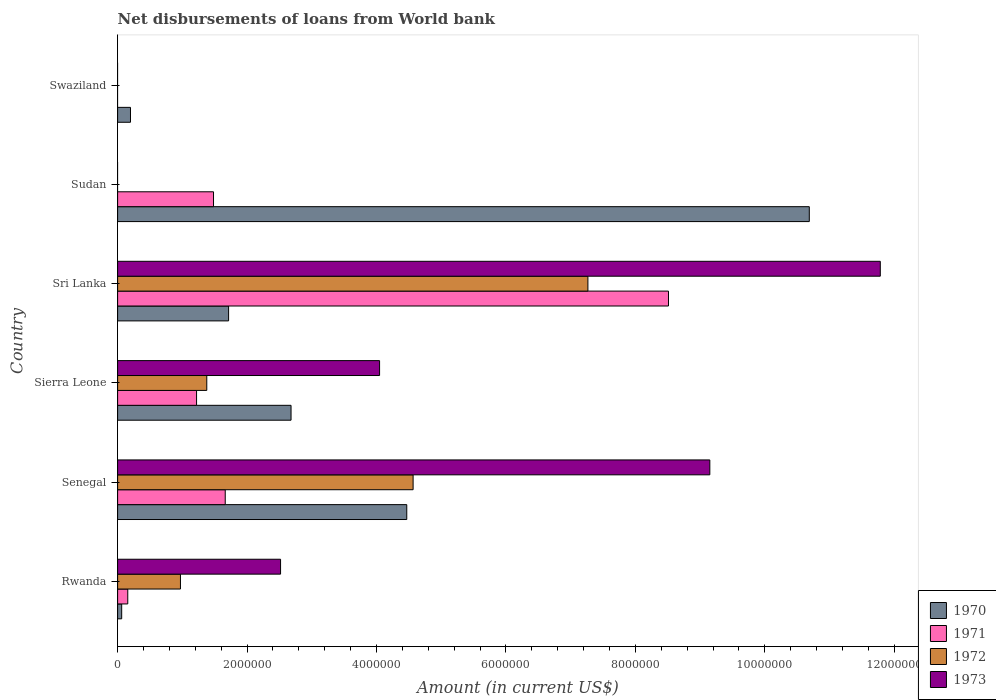How many different coloured bars are there?
Provide a succinct answer. 4. What is the label of the 1st group of bars from the top?
Your answer should be compact. Swaziland. What is the amount of loan disbursed from World Bank in 1971 in Swaziland?
Provide a succinct answer. 0. Across all countries, what is the maximum amount of loan disbursed from World Bank in 1971?
Provide a succinct answer. 8.51e+06. In which country was the amount of loan disbursed from World Bank in 1973 maximum?
Provide a short and direct response. Sri Lanka. What is the total amount of loan disbursed from World Bank in 1971 in the graph?
Provide a succinct answer. 1.30e+07. What is the difference between the amount of loan disbursed from World Bank in 1971 in Sierra Leone and that in Sri Lanka?
Provide a short and direct response. -7.29e+06. What is the difference between the amount of loan disbursed from World Bank in 1972 in Sudan and the amount of loan disbursed from World Bank in 1973 in Sri Lanka?
Provide a short and direct response. -1.18e+07. What is the average amount of loan disbursed from World Bank in 1973 per country?
Provide a succinct answer. 4.58e+06. What is the difference between the amount of loan disbursed from World Bank in 1973 and amount of loan disbursed from World Bank in 1972 in Sri Lanka?
Your answer should be very brief. 4.52e+06. What is the ratio of the amount of loan disbursed from World Bank in 1971 in Senegal to that in Sri Lanka?
Your answer should be very brief. 0.2. Is the amount of loan disbursed from World Bank in 1970 in Rwanda less than that in Sudan?
Give a very brief answer. Yes. Is the difference between the amount of loan disbursed from World Bank in 1973 in Rwanda and Sierra Leone greater than the difference between the amount of loan disbursed from World Bank in 1972 in Rwanda and Sierra Leone?
Offer a terse response. No. What is the difference between the highest and the second highest amount of loan disbursed from World Bank in 1973?
Your response must be concise. 2.63e+06. What is the difference between the highest and the lowest amount of loan disbursed from World Bank in 1970?
Provide a short and direct response. 1.06e+07. Is the sum of the amount of loan disbursed from World Bank in 1971 in Sri Lanka and Sudan greater than the maximum amount of loan disbursed from World Bank in 1970 across all countries?
Offer a terse response. No. Is it the case that in every country, the sum of the amount of loan disbursed from World Bank in 1970 and amount of loan disbursed from World Bank in 1971 is greater than the sum of amount of loan disbursed from World Bank in 1973 and amount of loan disbursed from World Bank in 1972?
Your answer should be very brief. No. Is it the case that in every country, the sum of the amount of loan disbursed from World Bank in 1971 and amount of loan disbursed from World Bank in 1972 is greater than the amount of loan disbursed from World Bank in 1970?
Make the answer very short. No. How many bars are there?
Give a very brief answer. 19. Are all the bars in the graph horizontal?
Offer a very short reply. Yes. What is the difference between two consecutive major ticks on the X-axis?
Provide a short and direct response. 2.00e+06. Are the values on the major ticks of X-axis written in scientific E-notation?
Keep it short and to the point. No. How are the legend labels stacked?
Offer a terse response. Vertical. What is the title of the graph?
Offer a terse response. Net disbursements of loans from World bank. Does "2012" appear as one of the legend labels in the graph?
Ensure brevity in your answer.  No. What is the label or title of the Y-axis?
Your answer should be compact. Country. What is the Amount (in current US$) in 1970 in Rwanda?
Your answer should be compact. 6.30e+04. What is the Amount (in current US$) in 1971 in Rwanda?
Provide a succinct answer. 1.57e+05. What is the Amount (in current US$) in 1972 in Rwanda?
Provide a succinct answer. 9.71e+05. What is the Amount (in current US$) in 1973 in Rwanda?
Your answer should be very brief. 2.52e+06. What is the Amount (in current US$) of 1970 in Senegal?
Give a very brief answer. 4.47e+06. What is the Amount (in current US$) of 1971 in Senegal?
Give a very brief answer. 1.66e+06. What is the Amount (in current US$) in 1972 in Senegal?
Ensure brevity in your answer.  4.57e+06. What is the Amount (in current US$) of 1973 in Senegal?
Your response must be concise. 9.15e+06. What is the Amount (in current US$) in 1970 in Sierra Leone?
Provide a short and direct response. 2.68e+06. What is the Amount (in current US$) in 1971 in Sierra Leone?
Your response must be concise. 1.22e+06. What is the Amount (in current US$) in 1972 in Sierra Leone?
Your answer should be compact. 1.38e+06. What is the Amount (in current US$) of 1973 in Sierra Leone?
Your response must be concise. 4.05e+06. What is the Amount (in current US$) in 1970 in Sri Lanka?
Your answer should be compact. 1.72e+06. What is the Amount (in current US$) in 1971 in Sri Lanka?
Give a very brief answer. 8.51e+06. What is the Amount (in current US$) of 1972 in Sri Lanka?
Ensure brevity in your answer.  7.27e+06. What is the Amount (in current US$) of 1973 in Sri Lanka?
Provide a short and direct response. 1.18e+07. What is the Amount (in current US$) in 1970 in Sudan?
Provide a succinct answer. 1.07e+07. What is the Amount (in current US$) of 1971 in Sudan?
Your answer should be very brief. 1.48e+06. What is the Amount (in current US$) of 1972 in Sudan?
Your answer should be compact. 0. What is the Amount (in current US$) in 1970 in Swaziland?
Ensure brevity in your answer.  1.99e+05. What is the Amount (in current US$) in 1972 in Swaziland?
Give a very brief answer. 0. Across all countries, what is the maximum Amount (in current US$) in 1970?
Provide a short and direct response. 1.07e+07. Across all countries, what is the maximum Amount (in current US$) in 1971?
Ensure brevity in your answer.  8.51e+06. Across all countries, what is the maximum Amount (in current US$) of 1972?
Ensure brevity in your answer.  7.27e+06. Across all countries, what is the maximum Amount (in current US$) in 1973?
Offer a very short reply. 1.18e+07. Across all countries, what is the minimum Amount (in current US$) of 1970?
Keep it short and to the point. 6.30e+04. Across all countries, what is the minimum Amount (in current US$) of 1971?
Ensure brevity in your answer.  0. Across all countries, what is the minimum Amount (in current US$) of 1972?
Offer a terse response. 0. What is the total Amount (in current US$) of 1970 in the graph?
Your answer should be compact. 1.98e+07. What is the total Amount (in current US$) in 1971 in the graph?
Keep it short and to the point. 1.30e+07. What is the total Amount (in current US$) of 1972 in the graph?
Give a very brief answer. 1.42e+07. What is the total Amount (in current US$) in 1973 in the graph?
Give a very brief answer. 2.75e+07. What is the difference between the Amount (in current US$) of 1970 in Rwanda and that in Senegal?
Offer a very short reply. -4.40e+06. What is the difference between the Amount (in current US$) in 1971 in Rwanda and that in Senegal?
Provide a succinct answer. -1.51e+06. What is the difference between the Amount (in current US$) in 1972 in Rwanda and that in Senegal?
Make the answer very short. -3.60e+06. What is the difference between the Amount (in current US$) in 1973 in Rwanda and that in Senegal?
Your answer should be compact. -6.63e+06. What is the difference between the Amount (in current US$) in 1970 in Rwanda and that in Sierra Leone?
Your answer should be compact. -2.62e+06. What is the difference between the Amount (in current US$) of 1971 in Rwanda and that in Sierra Leone?
Keep it short and to the point. -1.06e+06. What is the difference between the Amount (in current US$) of 1972 in Rwanda and that in Sierra Leone?
Make the answer very short. -4.07e+05. What is the difference between the Amount (in current US$) in 1973 in Rwanda and that in Sierra Leone?
Provide a short and direct response. -1.53e+06. What is the difference between the Amount (in current US$) in 1970 in Rwanda and that in Sri Lanka?
Provide a succinct answer. -1.65e+06. What is the difference between the Amount (in current US$) of 1971 in Rwanda and that in Sri Lanka?
Provide a short and direct response. -8.36e+06. What is the difference between the Amount (in current US$) of 1972 in Rwanda and that in Sri Lanka?
Provide a succinct answer. -6.30e+06. What is the difference between the Amount (in current US$) in 1973 in Rwanda and that in Sri Lanka?
Ensure brevity in your answer.  -9.27e+06. What is the difference between the Amount (in current US$) of 1970 in Rwanda and that in Sudan?
Make the answer very short. -1.06e+07. What is the difference between the Amount (in current US$) in 1971 in Rwanda and that in Sudan?
Ensure brevity in your answer.  -1.32e+06. What is the difference between the Amount (in current US$) in 1970 in Rwanda and that in Swaziland?
Provide a succinct answer. -1.36e+05. What is the difference between the Amount (in current US$) of 1970 in Senegal and that in Sierra Leone?
Offer a terse response. 1.79e+06. What is the difference between the Amount (in current US$) in 1971 in Senegal and that in Sierra Leone?
Keep it short and to the point. 4.43e+05. What is the difference between the Amount (in current US$) in 1972 in Senegal and that in Sierra Leone?
Keep it short and to the point. 3.19e+06. What is the difference between the Amount (in current US$) in 1973 in Senegal and that in Sierra Leone?
Make the answer very short. 5.10e+06. What is the difference between the Amount (in current US$) of 1970 in Senegal and that in Sri Lanka?
Offer a terse response. 2.75e+06. What is the difference between the Amount (in current US$) of 1971 in Senegal and that in Sri Lanka?
Make the answer very short. -6.85e+06. What is the difference between the Amount (in current US$) of 1972 in Senegal and that in Sri Lanka?
Give a very brief answer. -2.70e+06. What is the difference between the Amount (in current US$) in 1973 in Senegal and that in Sri Lanka?
Your answer should be compact. -2.63e+06. What is the difference between the Amount (in current US$) of 1970 in Senegal and that in Sudan?
Offer a very short reply. -6.22e+06. What is the difference between the Amount (in current US$) of 1971 in Senegal and that in Sudan?
Your answer should be very brief. 1.81e+05. What is the difference between the Amount (in current US$) in 1970 in Senegal and that in Swaziland?
Your answer should be very brief. 4.27e+06. What is the difference between the Amount (in current US$) of 1970 in Sierra Leone and that in Sri Lanka?
Give a very brief answer. 9.65e+05. What is the difference between the Amount (in current US$) in 1971 in Sierra Leone and that in Sri Lanka?
Give a very brief answer. -7.29e+06. What is the difference between the Amount (in current US$) in 1972 in Sierra Leone and that in Sri Lanka?
Provide a succinct answer. -5.89e+06. What is the difference between the Amount (in current US$) in 1973 in Sierra Leone and that in Sri Lanka?
Keep it short and to the point. -7.74e+06. What is the difference between the Amount (in current US$) of 1970 in Sierra Leone and that in Sudan?
Ensure brevity in your answer.  -8.01e+06. What is the difference between the Amount (in current US$) of 1971 in Sierra Leone and that in Sudan?
Your response must be concise. -2.62e+05. What is the difference between the Amount (in current US$) of 1970 in Sierra Leone and that in Swaziland?
Offer a very short reply. 2.48e+06. What is the difference between the Amount (in current US$) in 1970 in Sri Lanka and that in Sudan?
Offer a terse response. -8.97e+06. What is the difference between the Amount (in current US$) in 1971 in Sri Lanka and that in Sudan?
Your answer should be compact. 7.03e+06. What is the difference between the Amount (in current US$) in 1970 in Sri Lanka and that in Swaziland?
Your answer should be very brief. 1.52e+06. What is the difference between the Amount (in current US$) of 1970 in Sudan and that in Swaziland?
Ensure brevity in your answer.  1.05e+07. What is the difference between the Amount (in current US$) in 1970 in Rwanda and the Amount (in current US$) in 1971 in Senegal?
Your response must be concise. -1.60e+06. What is the difference between the Amount (in current US$) of 1970 in Rwanda and the Amount (in current US$) of 1972 in Senegal?
Your answer should be compact. -4.50e+06. What is the difference between the Amount (in current US$) of 1970 in Rwanda and the Amount (in current US$) of 1973 in Senegal?
Ensure brevity in your answer.  -9.09e+06. What is the difference between the Amount (in current US$) of 1971 in Rwanda and the Amount (in current US$) of 1972 in Senegal?
Keep it short and to the point. -4.41e+06. What is the difference between the Amount (in current US$) in 1971 in Rwanda and the Amount (in current US$) in 1973 in Senegal?
Your answer should be very brief. -8.99e+06. What is the difference between the Amount (in current US$) of 1972 in Rwanda and the Amount (in current US$) of 1973 in Senegal?
Offer a very short reply. -8.18e+06. What is the difference between the Amount (in current US$) in 1970 in Rwanda and the Amount (in current US$) in 1971 in Sierra Leone?
Offer a terse response. -1.16e+06. What is the difference between the Amount (in current US$) of 1970 in Rwanda and the Amount (in current US$) of 1972 in Sierra Leone?
Provide a short and direct response. -1.32e+06. What is the difference between the Amount (in current US$) in 1970 in Rwanda and the Amount (in current US$) in 1973 in Sierra Leone?
Your answer should be very brief. -3.98e+06. What is the difference between the Amount (in current US$) in 1971 in Rwanda and the Amount (in current US$) in 1972 in Sierra Leone?
Offer a very short reply. -1.22e+06. What is the difference between the Amount (in current US$) in 1971 in Rwanda and the Amount (in current US$) in 1973 in Sierra Leone?
Provide a short and direct response. -3.89e+06. What is the difference between the Amount (in current US$) of 1972 in Rwanda and the Amount (in current US$) of 1973 in Sierra Leone?
Give a very brief answer. -3.08e+06. What is the difference between the Amount (in current US$) in 1970 in Rwanda and the Amount (in current US$) in 1971 in Sri Lanka?
Provide a short and direct response. -8.45e+06. What is the difference between the Amount (in current US$) in 1970 in Rwanda and the Amount (in current US$) in 1972 in Sri Lanka?
Your response must be concise. -7.20e+06. What is the difference between the Amount (in current US$) in 1970 in Rwanda and the Amount (in current US$) in 1973 in Sri Lanka?
Your answer should be very brief. -1.17e+07. What is the difference between the Amount (in current US$) of 1971 in Rwanda and the Amount (in current US$) of 1972 in Sri Lanka?
Offer a terse response. -7.11e+06. What is the difference between the Amount (in current US$) of 1971 in Rwanda and the Amount (in current US$) of 1973 in Sri Lanka?
Offer a very short reply. -1.16e+07. What is the difference between the Amount (in current US$) of 1972 in Rwanda and the Amount (in current US$) of 1973 in Sri Lanka?
Your answer should be very brief. -1.08e+07. What is the difference between the Amount (in current US$) of 1970 in Rwanda and the Amount (in current US$) of 1971 in Sudan?
Offer a very short reply. -1.42e+06. What is the difference between the Amount (in current US$) of 1970 in Senegal and the Amount (in current US$) of 1971 in Sierra Leone?
Offer a terse response. 3.25e+06. What is the difference between the Amount (in current US$) of 1970 in Senegal and the Amount (in current US$) of 1972 in Sierra Leone?
Make the answer very short. 3.09e+06. What is the difference between the Amount (in current US$) of 1970 in Senegal and the Amount (in current US$) of 1973 in Sierra Leone?
Provide a short and direct response. 4.20e+05. What is the difference between the Amount (in current US$) of 1971 in Senegal and the Amount (in current US$) of 1972 in Sierra Leone?
Ensure brevity in your answer.  2.85e+05. What is the difference between the Amount (in current US$) in 1971 in Senegal and the Amount (in current US$) in 1973 in Sierra Leone?
Offer a very short reply. -2.38e+06. What is the difference between the Amount (in current US$) in 1972 in Senegal and the Amount (in current US$) in 1973 in Sierra Leone?
Give a very brief answer. 5.18e+05. What is the difference between the Amount (in current US$) in 1970 in Senegal and the Amount (in current US$) in 1971 in Sri Lanka?
Your answer should be compact. -4.04e+06. What is the difference between the Amount (in current US$) of 1970 in Senegal and the Amount (in current US$) of 1972 in Sri Lanka?
Your response must be concise. -2.80e+06. What is the difference between the Amount (in current US$) in 1970 in Senegal and the Amount (in current US$) in 1973 in Sri Lanka?
Offer a very short reply. -7.32e+06. What is the difference between the Amount (in current US$) in 1971 in Senegal and the Amount (in current US$) in 1972 in Sri Lanka?
Give a very brief answer. -5.60e+06. What is the difference between the Amount (in current US$) in 1971 in Senegal and the Amount (in current US$) in 1973 in Sri Lanka?
Offer a terse response. -1.01e+07. What is the difference between the Amount (in current US$) in 1972 in Senegal and the Amount (in current US$) in 1973 in Sri Lanka?
Your response must be concise. -7.22e+06. What is the difference between the Amount (in current US$) in 1970 in Senegal and the Amount (in current US$) in 1971 in Sudan?
Provide a short and direct response. 2.99e+06. What is the difference between the Amount (in current US$) in 1970 in Sierra Leone and the Amount (in current US$) in 1971 in Sri Lanka?
Your answer should be compact. -5.83e+06. What is the difference between the Amount (in current US$) in 1970 in Sierra Leone and the Amount (in current US$) in 1972 in Sri Lanka?
Provide a succinct answer. -4.59e+06. What is the difference between the Amount (in current US$) in 1970 in Sierra Leone and the Amount (in current US$) in 1973 in Sri Lanka?
Keep it short and to the point. -9.10e+06. What is the difference between the Amount (in current US$) of 1971 in Sierra Leone and the Amount (in current US$) of 1972 in Sri Lanka?
Provide a short and direct response. -6.05e+06. What is the difference between the Amount (in current US$) of 1971 in Sierra Leone and the Amount (in current US$) of 1973 in Sri Lanka?
Make the answer very short. -1.06e+07. What is the difference between the Amount (in current US$) of 1972 in Sierra Leone and the Amount (in current US$) of 1973 in Sri Lanka?
Give a very brief answer. -1.04e+07. What is the difference between the Amount (in current US$) in 1970 in Sierra Leone and the Amount (in current US$) in 1971 in Sudan?
Provide a short and direct response. 1.20e+06. What is the difference between the Amount (in current US$) of 1970 in Sri Lanka and the Amount (in current US$) of 1971 in Sudan?
Provide a succinct answer. 2.33e+05. What is the average Amount (in current US$) of 1970 per country?
Your response must be concise. 3.30e+06. What is the average Amount (in current US$) of 1971 per country?
Offer a very short reply. 2.17e+06. What is the average Amount (in current US$) in 1972 per country?
Offer a very short reply. 2.36e+06. What is the average Amount (in current US$) in 1973 per country?
Give a very brief answer. 4.58e+06. What is the difference between the Amount (in current US$) in 1970 and Amount (in current US$) in 1971 in Rwanda?
Give a very brief answer. -9.40e+04. What is the difference between the Amount (in current US$) in 1970 and Amount (in current US$) in 1972 in Rwanda?
Make the answer very short. -9.08e+05. What is the difference between the Amount (in current US$) in 1970 and Amount (in current US$) in 1973 in Rwanda?
Make the answer very short. -2.46e+06. What is the difference between the Amount (in current US$) in 1971 and Amount (in current US$) in 1972 in Rwanda?
Your response must be concise. -8.14e+05. What is the difference between the Amount (in current US$) in 1971 and Amount (in current US$) in 1973 in Rwanda?
Provide a succinct answer. -2.36e+06. What is the difference between the Amount (in current US$) in 1972 and Amount (in current US$) in 1973 in Rwanda?
Your answer should be very brief. -1.55e+06. What is the difference between the Amount (in current US$) in 1970 and Amount (in current US$) in 1971 in Senegal?
Offer a very short reply. 2.80e+06. What is the difference between the Amount (in current US$) of 1970 and Amount (in current US$) of 1972 in Senegal?
Provide a short and direct response. -9.80e+04. What is the difference between the Amount (in current US$) in 1970 and Amount (in current US$) in 1973 in Senegal?
Provide a succinct answer. -4.68e+06. What is the difference between the Amount (in current US$) of 1971 and Amount (in current US$) of 1972 in Senegal?
Ensure brevity in your answer.  -2.90e+06. What is the difference between the Amount (in current US$) in 1971 and Amount (in current US$) in 1973 in Senegal?
Provide a succinct answer. -7.49e+06. What is the difference between the Amount (in current US$) in 1972 and Amount (in current US$) in 1973 in Senegal?
Provide a short and direct response. -4.58e+06. What is the difference between the Amount (in current US$) in 1970 and Amount (in current US$) in 1971 in Sierra Leone?
Offer a terse response. 1.46e+06. What is the difference between the Amount (in current US$) in 1970 and Amount (in current US$) in 1972 in Sierra Leone?
Give a very brief answer. 1.30e+06. What is the difference between the Amount (in current US$) of 1970 and Amount (in current US$) of 1973 in Sierra Leone?
Ensure brevity in your answer.  -1.37e+06. What is the difference between the Amount (in current US$) of 1971 and Amount (in current US$) of 1972 in Sierra Leone?
Your answer should be very brief. -1.58e+05. What is the difference between the Amount (in current US$) in 1971 and Amount (in current US$) in 1973 in Sierra Leone?
Keep it short and to the point. -2.83e+06. What is the difference between the Amount (in current US$) in 1972 and Amount (in current US$) in 1973 in Sierra Leone?
Your answer should be very brief. -2.67e+06. What is the difference between the Amount (in current US$) of 1970 and Amount (in current US$) of 1971 in Sri Lanka?
Your response must be concise. -6.80e+06. What is the difference between the Amount (in current US$) in 1970 and Amount (in current US$) in 1972 in Sri Lanka?
Offer a very short reply. -5.55e+06. What is the difference between the Amount (in current US$) of 1970 and Amount (in current US$) of 1973 in Sri Lanka?
Your answer should be very brief. -1.01e+07. What is the difference between the Amount (in current US$) of 1971 and Amount (in current US$) of 1972 in Sri Lanka?
Your response must be concise. 1.24e+06. What is the difference between the Amount (in current US$) in 1971 and Amount (in current US$) in 1973 in Sri Lanka?
Your answer should be very brief. -3.27e+06. What is the difference between the Amount (in current US$) of 1972 and Amount (in current US$) of 1973 in Sri Lanka?
Offer a very short reply. -4.52e+06. What is the difference between the Amount (in current US$) of 1970 and Amount (in current US$) of 1971 in Sudan?
Give a very brief answer. 9.21e+06. What is the ratio of the Amount (in current US$) in 1970 in Rwanda to that in Senegal?
Offer a very short reply. 0.01. What is the ratio of the Amount (in current US$) of 1971 in Rwanda to that in Senegal?
Your response must be concise. 0.09. What is the ratio of the Amount (in current US$) of 1972 in Rwanda to that in Senegal?
Provide a succinct answer. 0.21. What is the ratio of the Amount (in current US$) of 1973 in Rwanda to that in Senegal?
Offer a terse response. 0.28. What is the ratio of the Amount (in current US$) of 1970 in Rwanda to that in Sierra Leone?
Ensure brevity in your answer.  0.02. What is the ratio of the Amount (in current US$) in 1971 in Rwanda to that in Sierra Leone?
Provide a succinct answer. 0.13. What is the ratio of the Amount (in current US$) of 1972 in Rwanda to that in Sierra Leone?
Your response must be concise. 0.7. What is the ratio of the Amount (in current US$) in 1973 in Rwanda to that in Sierra Leone?
Your answer should be compact. 0.62. What is the ratio of the Amount (in current US$) of 1970 in Rwanda to that in Sri Lanka?
Make the answer very short. 0.04. What is the ratio of the Amount (in current US$) in 1971 in Rwanda to that in Sri Lanka?
Keep it short and to the point. 0.02. What is the ratio of the Amount (in current US$) of 1972 in Rwanda to that in Sri Lanka?
Keep it short and to the point. 0.13. What is the ratio of the Amount (in current US$) of 1973 in Rwanda to that in Sri Lanka?
Give a very brief answer. 0.21. What is the ratio of the Amount (in current US$) in 1970 in Rwanda to that in Sudan?
Your response must be concise. 0.01. What is the ratio of the Amount (in current US$) in 1971 in Rwanda to that in Sudan?
Ensure brevity in your answer.  0.11. What is the ratio of the Amount (in current US$) in 1970 in Rwanda to that in Swaziland?
Keep it short and to the point. 0.32. What is the ratio of the Amount (in current US$) in 1970 in Senegal to that in Sierra Leone?
Provide a succinct answer. 1.67. What is the ratio of the Amount (in current US$) of 1971 in Senegal to that in Sierra Leone?
Ensure brevity in your answer.  1.36. What is the ratio of the Amount (in current US$) in 1972 in Senegal to that in Sierra Leone?
Keep it short and to the point. 3.31. What is the ratio of the Amount (in current US$) of 1973 in Senegal to that in Sierra Leone?
Offer a terse response. 2.26. What is the ratio of the Amount (in current US$) in 1970 in Senegal to that in Sri Lanka?
Your answer should be compact. 2.61. What is the ratio of the Amount (in current US$) in 1971 in Senegal to that in Sri Lanka?
Give a very brief answer. 0.2. What is the ratio of the Amount (in current US$) in 1972 in Senegal to that in Sri Lanka?
Provide a succinct answer. 0.63. What is the ratio of the Amount (in current US$) of 1973 in Senegal to that in Sri Lanka?
Offer a very short reply. 0.78. What is the ratio of the Amount (in current US$) in 1970 in Senegal to that in Sudan?
Offer a very short reply. 0.42. What is the ratio of the Amount (in current US$) in 1971 in Senegal to that in Sudan?
Keep it short and to the point. 1.12. What is the ratio of the Amount (in current US$) in 1970 in Senegal to that in Swaziland?
Ensure brevity in your answer.  22.45. What is the ratio of the Amount (in current US$) in 1970 in Sierra Leone to that in Sri Lanka?
Keep it short and to the point. 1.56. What is the ratio of the Amount (in current US$) of 1971 in Sierra Leone to that in Sri Lanka?
Offer a terse response. 0.14. What is the ratio of the Amount (in current US$) in 1972 in Sierra Leone to that in Sri Lanka?
Your answer should be very brief. 0.19. What is the ratio of the Amount (in current US$) in 1973 in Sierra Leone to that in Sri Lanka?
Offer a very short reply. 0.34. What is the ratio of the Amount (in current US$) in 1970 in Sierra Leone to that in Sudan?
Your response must be concise. 0.25. What is the ratio of the Amount (in current US$) of 1971 in Sierra Leone to that in Sudan?
Offer a terse response. 0.82. What is the ratio of the Amount (in current US$) in 1970 in Sierra Leone to that in Swaziland?
Your answer should be compact. 13.47. What is the ratio of the Amount (in current US$) of 1970 in Sri Lanka to that in Sudan?
Ensure brevity in your answer.  0.16. What is the ratio of the Amount (in current US$) of 1971 in Sri Lanka to that in Sudan?
Your answer should be very brief. 5.74. What is the ratio of the Amount (in current US$) in 1970 in Sri Lanka to that in Swaziland?
Make the answer very short. 8.62. What is the ratio of the Amount (in current US$) in 1970 in Sudan to that in Swaziland?
Make the answer very short. 53.71. What is the difference between the highest and the second highest Amount (in current US$) in 1970?
Your answer should be very brief. 6.22e+06. What is the difference between the highest and the second highest Amount (in current US$) of 1971?
Your response must be concise. 6.85e+06. What is the difference between the highest and the second highest Amount (in current US$) of 1972?
Offer a very short reply. 2.70e+06. What is the difference between the highest and the second highest Amount (in current US$) in 1973?
Offer a terse response. 2.63e+06. What is the difference between the highest and the lowest Amount (in current US$) in 1970?
Keep it short and to the point. 1.06e+07. What is the difference between the highest and the lowest Amount (in current US$) of 1971?
Provide a short and direct response. 8.51e+06. What is the difference between the highest and the lowest Amount (in current US$) of 1972?
Ensure brevity in your answer.  7.27e+06. What is the difference between the highest and the lowest Amount (in current US$) of 1973?
Your answer should be very brief. 1.18e+07. 